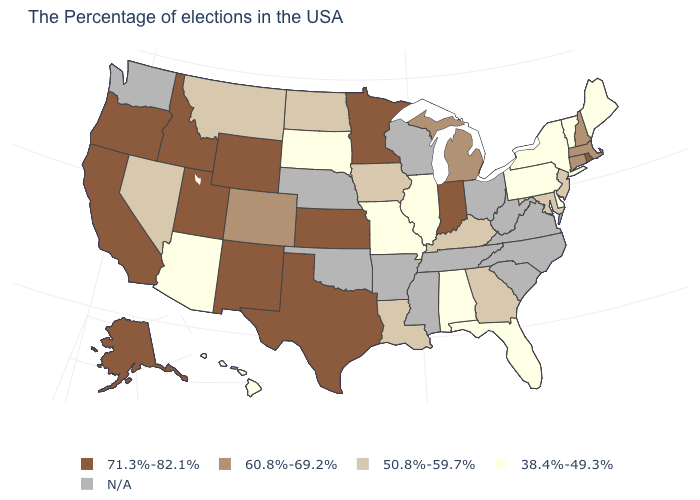Does Wyoming have the highest value in the West?
Write a very short answer. Yes. What is the value of West Virginia?
Write a very short answer. N/A. Name the states that have a value in the range 38.4%-49.3%?
Concise answer only. Maine, Vermont, New York, Delaware, Pennsylvania, Florida, Alabama, Illinois, Missouri, South Dakota, Arizona, Hawaii. Among the states that border Florida , does Georgia have the lowest value?
Quick response, please. No. Is the legend a continuous bar?
Quick response, please. No. Which states hav the highest value in the MidWest?
Answer briefly. Indiana, Minnesota, Kansas. What is the value of New Jersey?
Quick response, please. 50.8%-59.7%. Name the states that have a value in the range 38.4%-49.3%?
Short answer required. Maine, Vermont, New York, Delaware, Pennsylvania, Florida, Alabama, Illinois, Missouri, South Dakota, Arizona, Hawaii. What is the value of Illinois?
Quick response, please. 38.4%-49.3%. Name the states that have a value in the range 60.8%-69.2%?
Short answer required. Massachusetts, New Hampshire, Connecticut, Michigan, Colorado. What is the value of Hawaii?
Write a very short answer. 38.4%-49.3%. What is the value of Utah?
Quick response, please. 71.3%-82.1%. What is the value of South Dakota?
Write a very short answer. 38.4%-49.3%. 